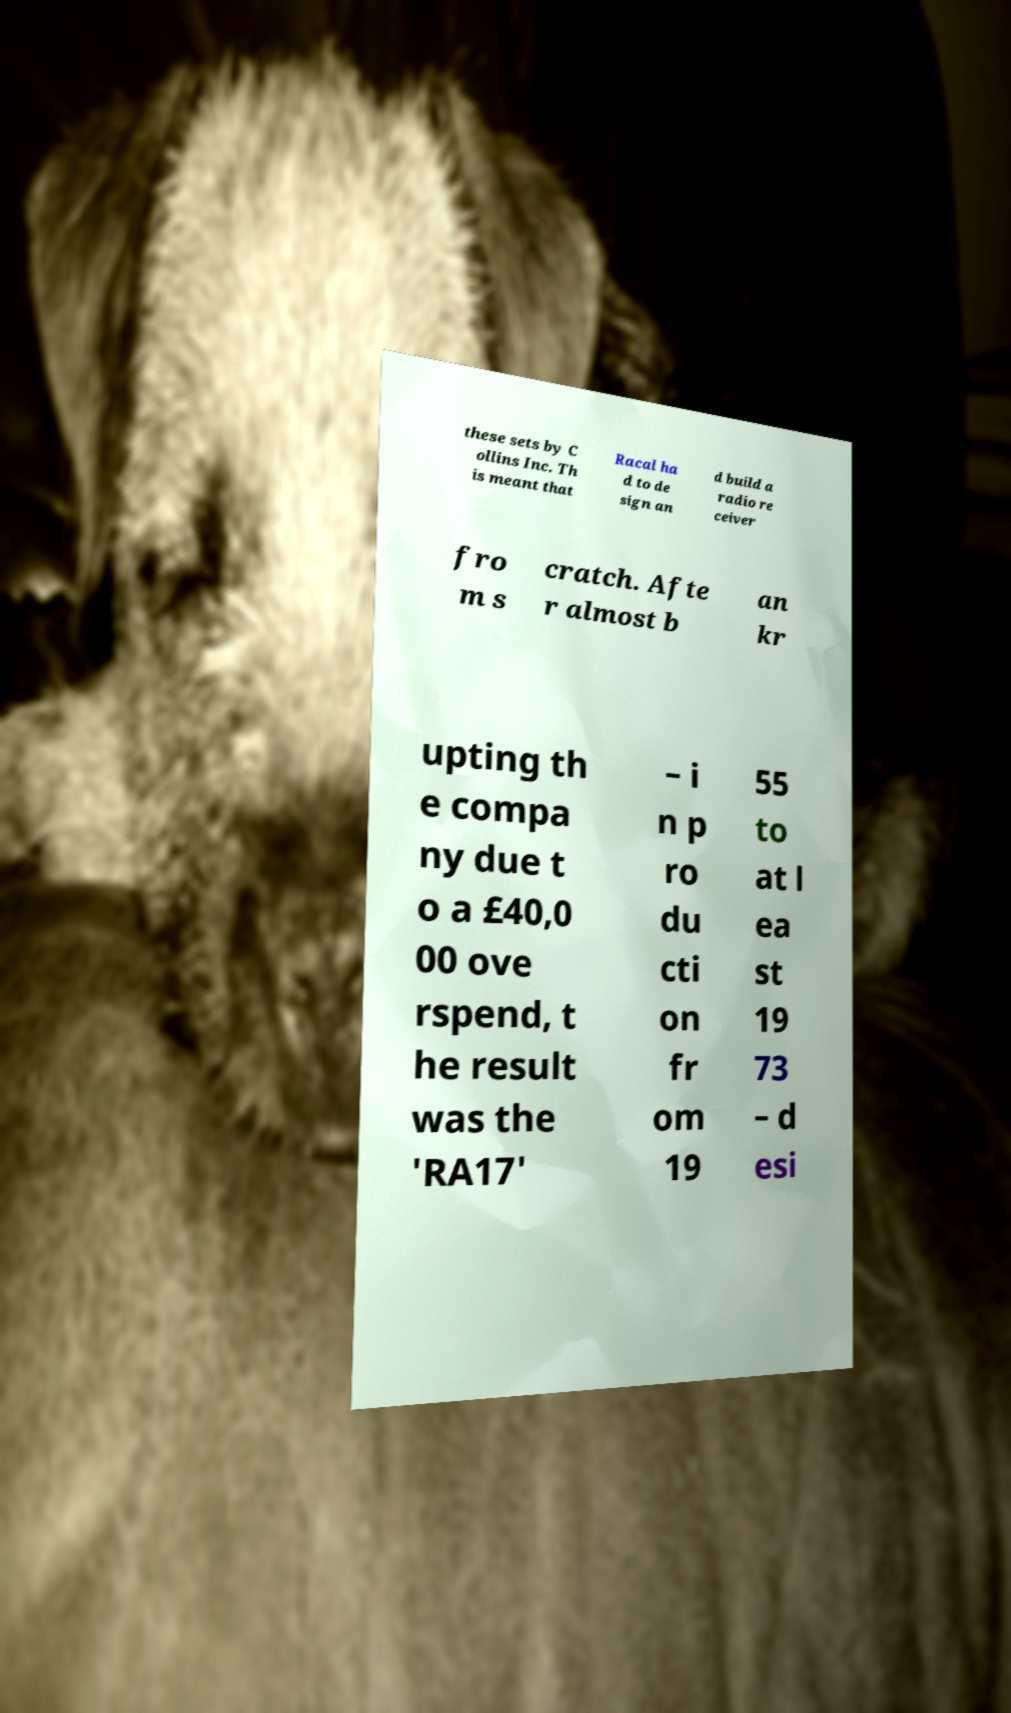What messages or text are displayed in this image? I need them in a readable, typed format. these sets by C ollins Inc. Th is meant that Racal ha d to de sign an d build a radio re ceiver fro m s cratch. Afte r almost b an kr upting th e compa ny due t o a £40,0 00 ove rspend, t he result was the 'RA17' – i n p ro du cti on fr om 19 55 to at l ea st 19 73 – d esi 